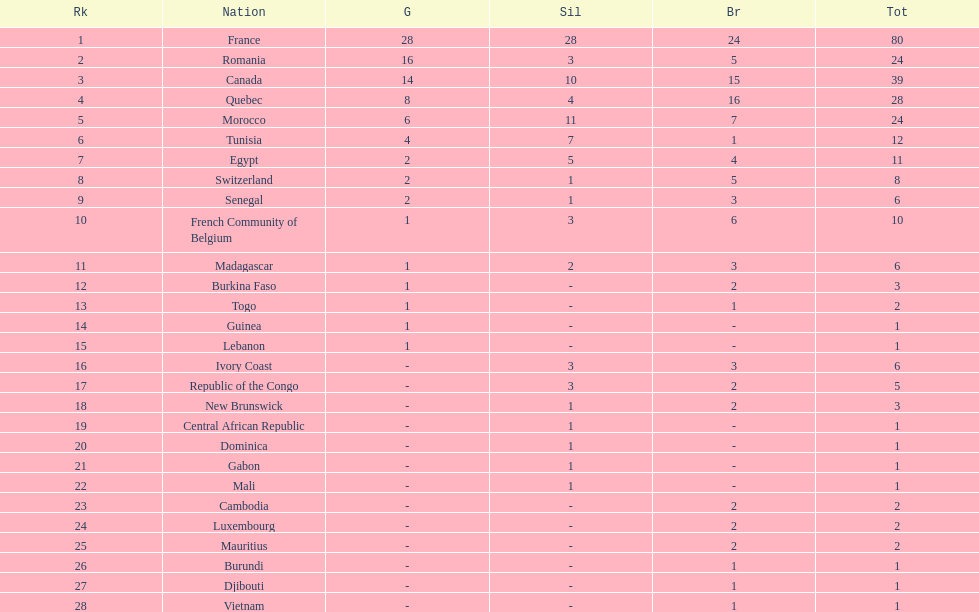What is the difference between france's and egypt's silver medals? 23. 